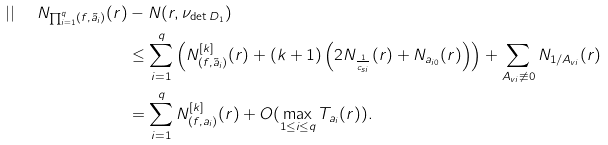Convert formula to latex. <formula><loc_0><loc_0><loc_500><loc_500>| | \ \ N _ { \prod _ { i = 1 } ^ { q } ( f , \tilde { a } _ { i } ) } ( r ) & - N ( r , \nu _ { \det D _ { 1 } } ) \\ & \leq \sum _ { i = 1 } ^ { q } \left ( N ^ { [ k ] } _ { ( f , \tilde { a } _ { i } ) } ( r ) + ( k + 1 ) \left ( 2 N _ { \frac { 1 } { c _ { s i } } } ( r ) + N _ { a _ { i 0 } } ( r ) \right ) \right ) + \sum _ { A _ { v i } \not \equiv 0 } N _ { { 1 } / { A _ { v i } } } ( r ) \\ & = \sum _ { i = 1 } ^ { q } N ^ { [ k ] } _ { ( f , a _ { i } ) } ( r ) + O ( \max _ { 1 \leq i \leq q } T _ { a _ { i } } ( r ) ) .</formula> 